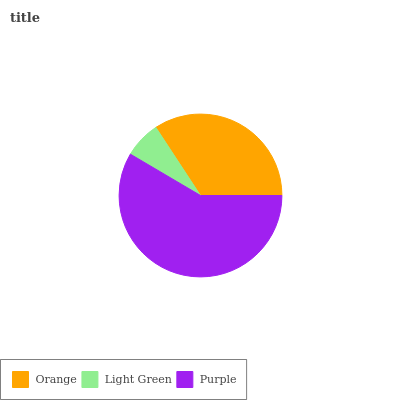Is Light Green the minimum?
Answer yes or no. Yes. Is Purple the maximum?
Answer yes or no. Yes. Is Purple the minimum?
Answer yes or no. No. Is Light Green the maximum?
Answer yes or no. No. Is Purple greater than Light Green?
Answer yes or no. Yes. Is Light Green less than Purple?
Answer yes or no. Yes. Is Light Green greater than Purple?
Answer yes or no. No. Is Purple less than Light Green?
Answer yes or no. No. Is Orange the high median?
Answer yes or no. Yes. Is Orange the low median?
Answer yes or no. Yes. Is Light Green the high median?
Answer yes or no. No. Is Light Green the low median?
Answer yes or no. No. 